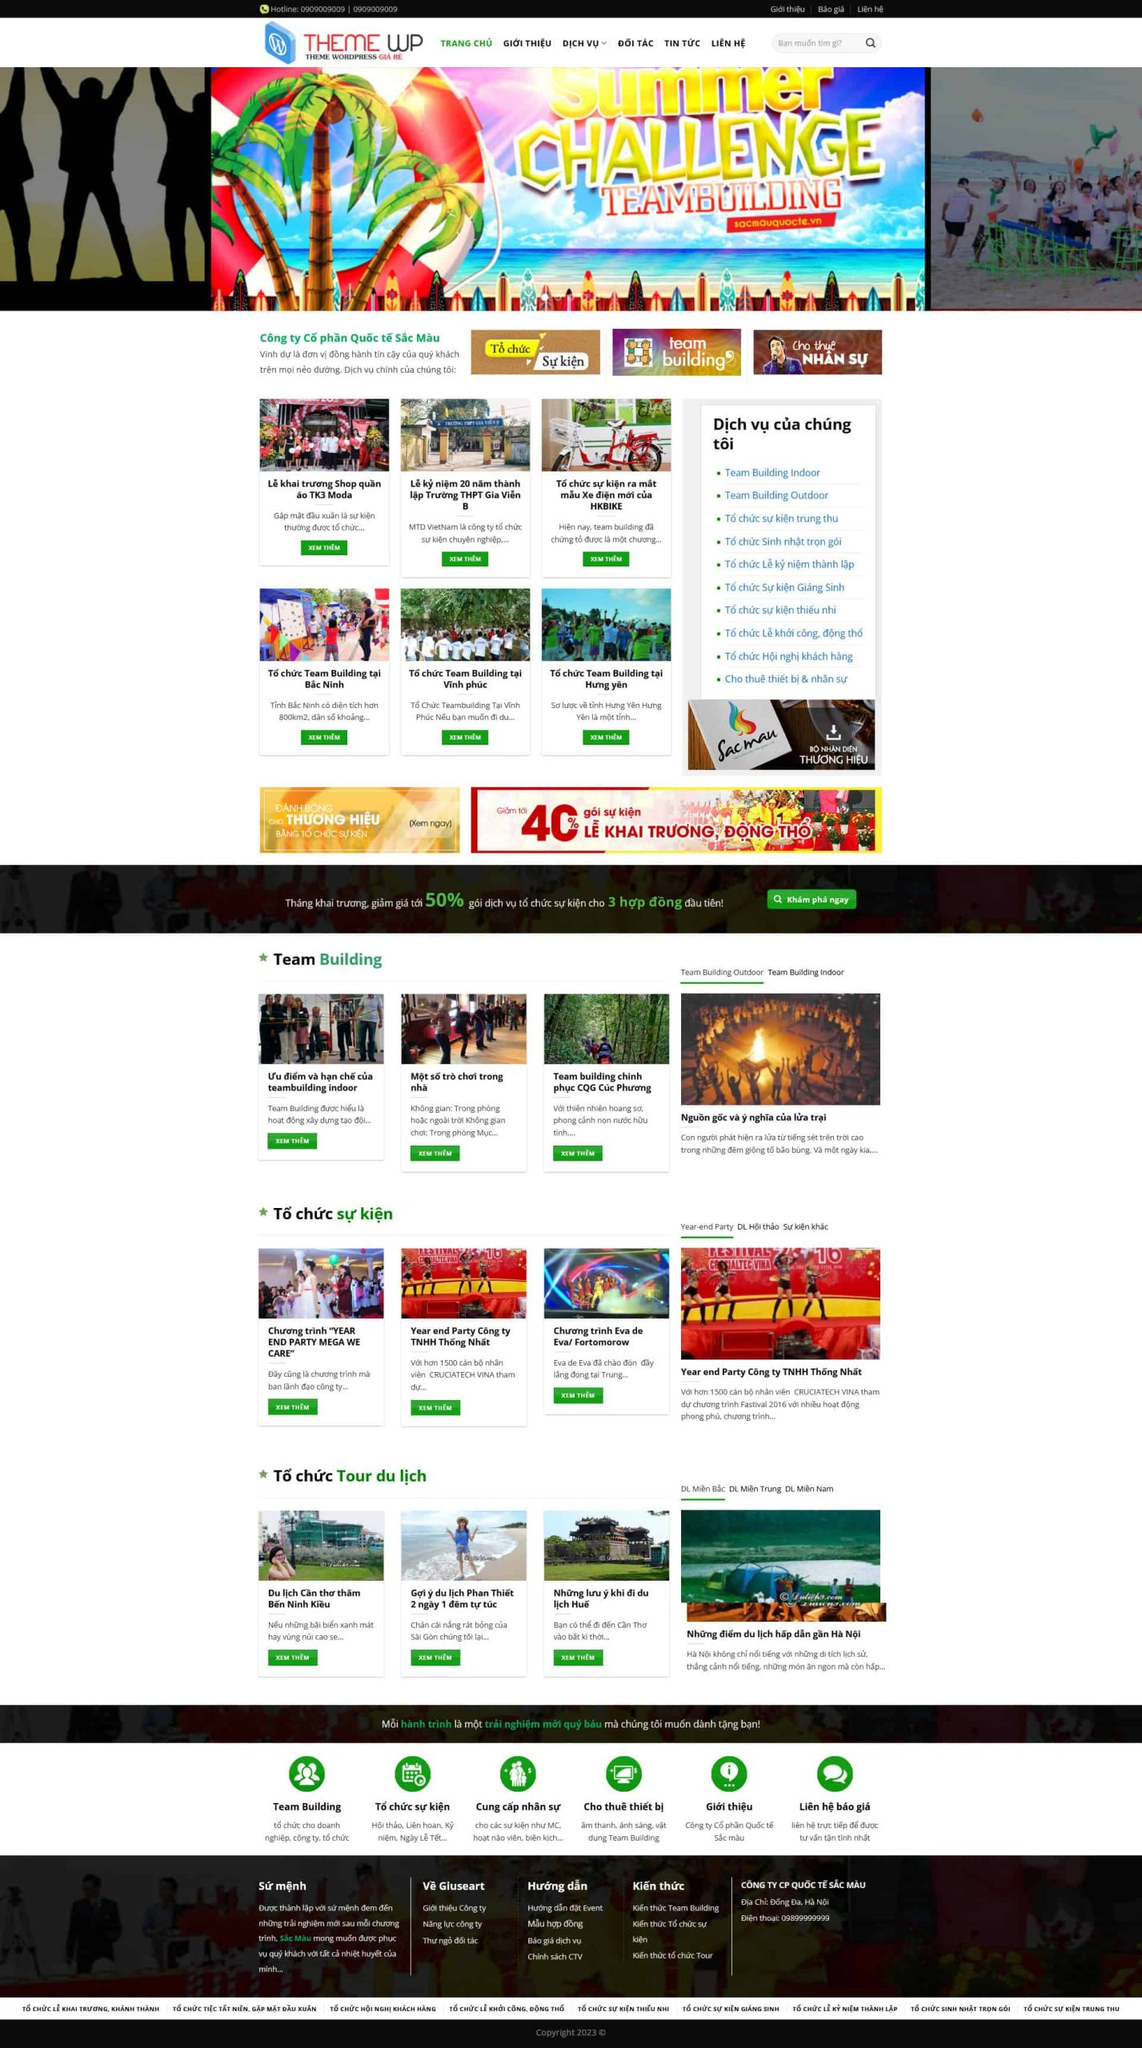Liệt kê 5 ngành nghề, lĩnh vực phù hợp với website này, phân cách các màu sắc bằng dấu phẩy. Chỉ trả về kết quả, phân cách bằng dấy phẩy
 Team Building, Tổ chức sự kiện, Tổ chức tour du lịch, Tổ chức hội nghị khách hàng, Chụp ảnh sự kiện 